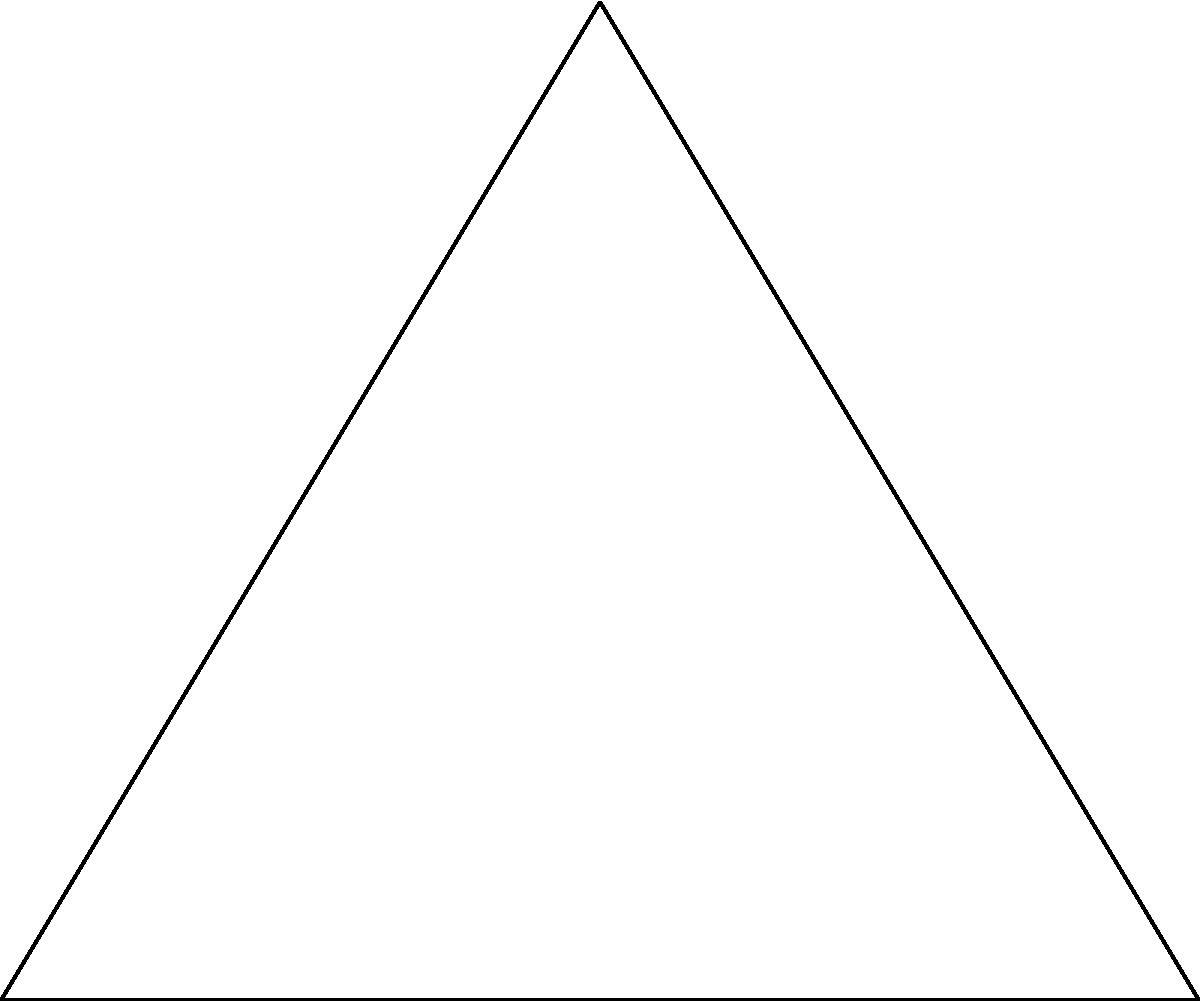At Club Deportivo Provincial Ranco's training ground, there's a triangular football pitch with sides measuring 6m, 8m, and 10m. The coaches want to place a circular sprinkler system at the center of the largest inscribed circle within this pitch. What is the radius of this circle to the nearest centimeter? Let's approach this step-by-step:

1) First, we need to recall the formula for the radius of an inscribed circle in a triangle:

   $$r = \frac{A}{s}$$

   where $r$ is the radius, $A$ is the area of the triangle, and $s$ is the semi-perimeter.

2) Calculate the semi-perimeter $s$:
   $$s = \frac{a + b + c}{2} = \frac{6 + 8 + 10}{2} = 12$$

3) Calculate the area $A$ using Heron's formula:
   $$A = \sqrt{s(s-a)(s-b)(s-c)}$$
   $$A = \sqrt{12(12-6)(12-8)(12-10)}$$
   $$A = \sqrt{12 \cdot 6 \cdot 4 \cdot 2}$$
   $$A = \sqrt{576} = 24$$

4) Now we can calculate the radius:
   $$r = \frac{A}{s} = \frac{24}{12} = 2$$

5) The radius is 2 meters or 200 centimeters.

Therefore, the radius of the largest inscribed circle is 200 cm.
Answer: 200 cm 